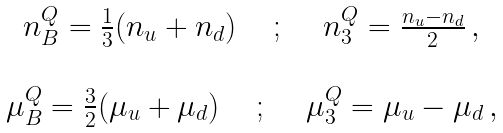<formula> <loc_0><loc_0><loc_500><loc_500>\begin{array} { c } n _ { B } ^ { Q } = \frac { 1 } { 3 } ( n _ { u } + n _ { d } ) \quad \, ; \, \quad n _ { 3 } ^ { Q } = \frac { n _ { u } - n _ { d } } { 2 } \, , \\ \\ \mu _ { B } ^ { Q } = \frac { 3 } { 2 } ( \mu _ { u } + \mu _ { d } ) \quad \, ; \, \quad \mu _ { 3 } ^ { Q } = \mu _ { u } - \mu _ { d } \, , \\ \end{array}</formula> 